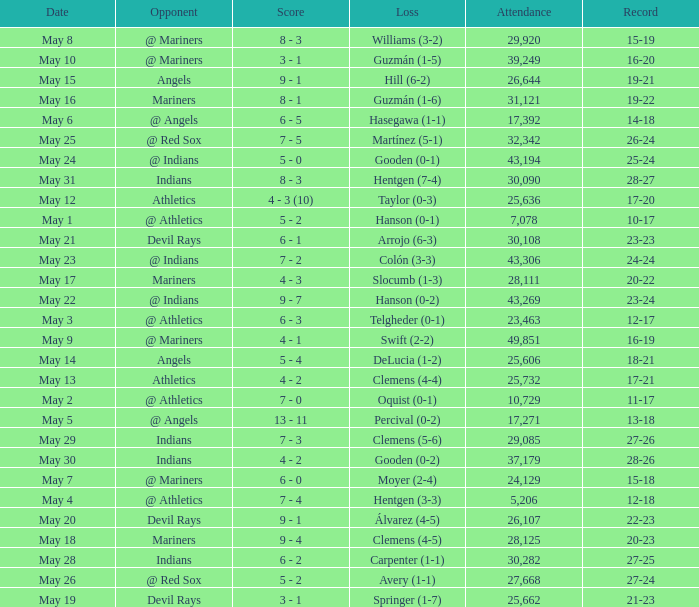For record 25-24, what is the sum of attendance? 1.0. 